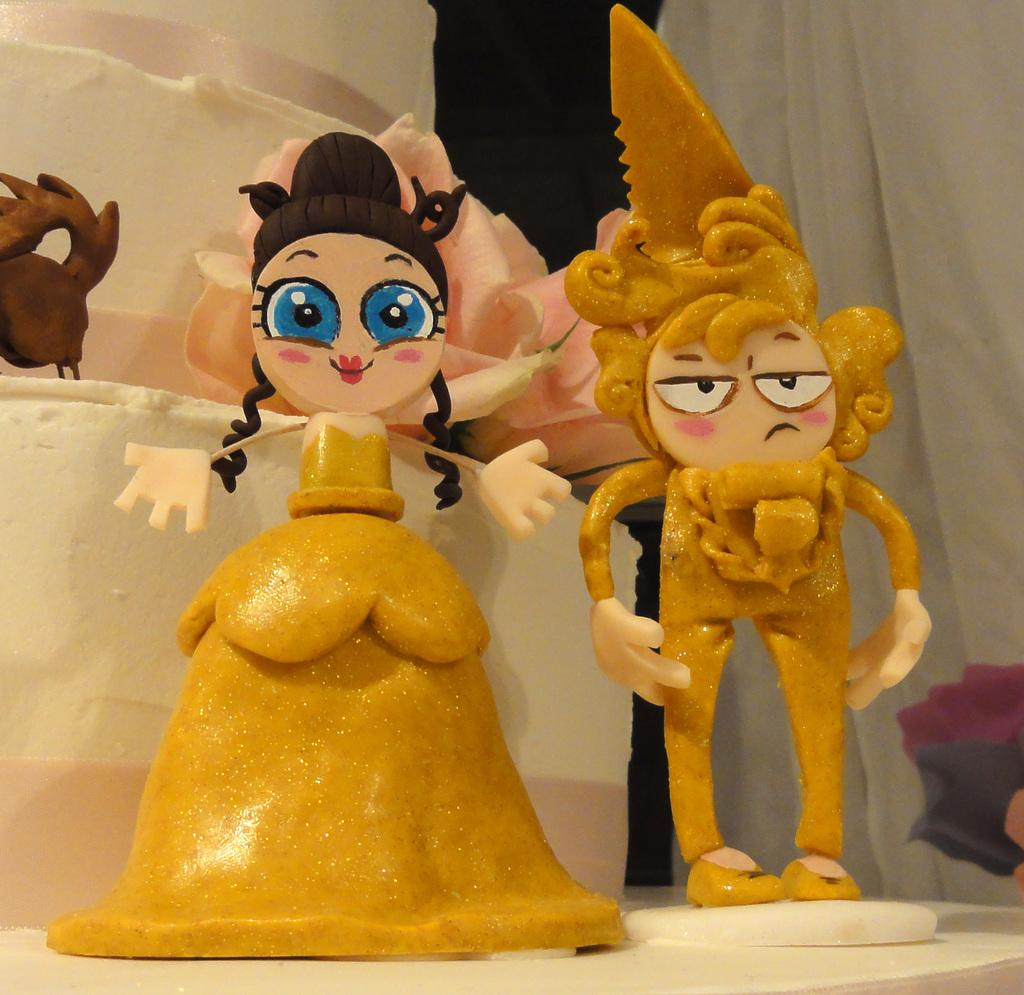What type of toy is depicted in the image? There is a toy of a girl in the image, but it is in the shape of a man. What is the color of the cake in the image? The cake in the image is white in color. Can you hear the toy laughing in the image? There is no sound in the image, so it is not possible to hear the toy laughing. 